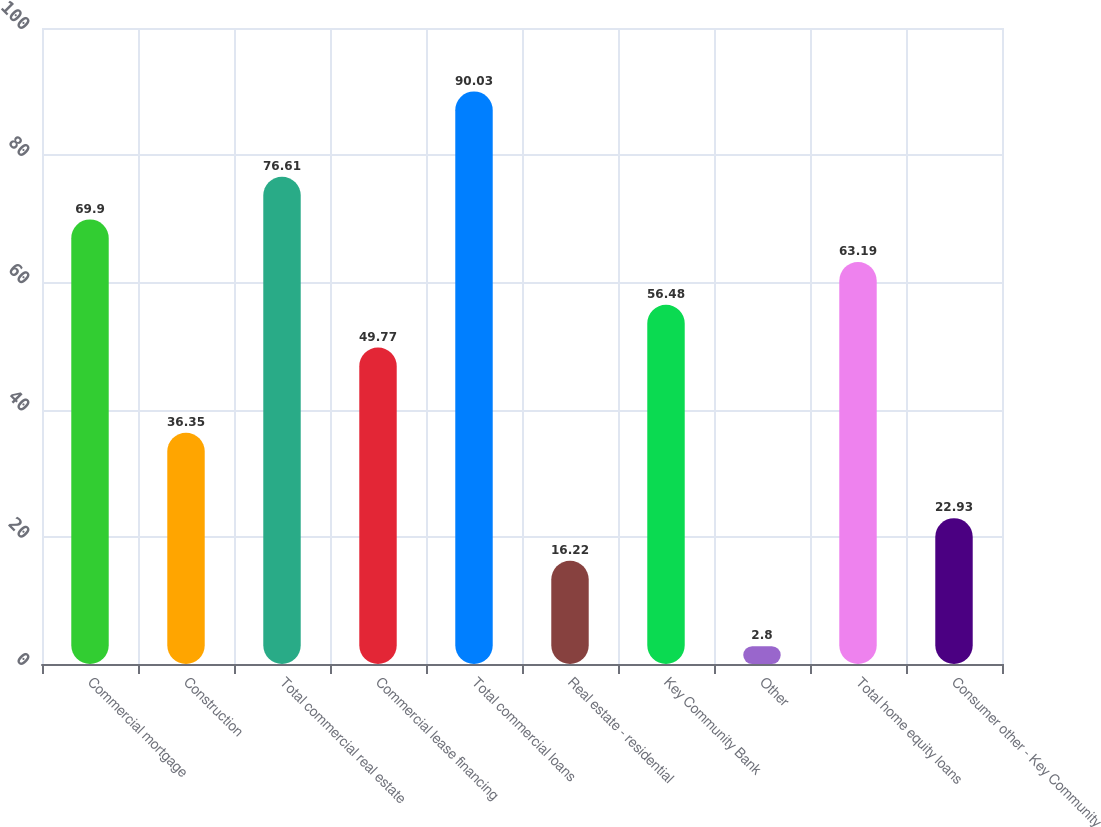<chart> <loc_0><loc_0><loc_500><loc_500><bar_chart><fcel>Commercial mortgage<fcel>Construction<fcel>Total commercial real estate<fcel>Commercial lease financing<fcel>Total commercial loans<fcel>Real estate - residential<fcel>Key Community Bank<fcel>Other<fcel>Total home equity loans<fcel>Consumer other - Key Community<nl><fcel>69.9<fcel>36.35<fcel>76.61<fcel>49.77<fcel>90.03<fcel>16.22<fcel>56.48<fcel>2.8<fcel>63.19<fcel>22.93<nl></chart> 